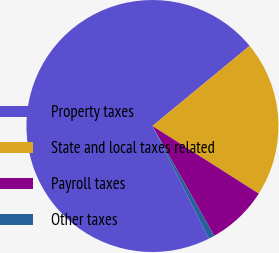<chart> <loc_0><loc_0><loc_500><loc_500><pie_chart><fcel>Property taxes<fcel>State and local taxes related<fcel>Payroll taxes<fcel>Other taxes<nl><fcel>71.42%<fcel>19.99%<fcel>7.83%<fcel>0.76%<nl></chart> 